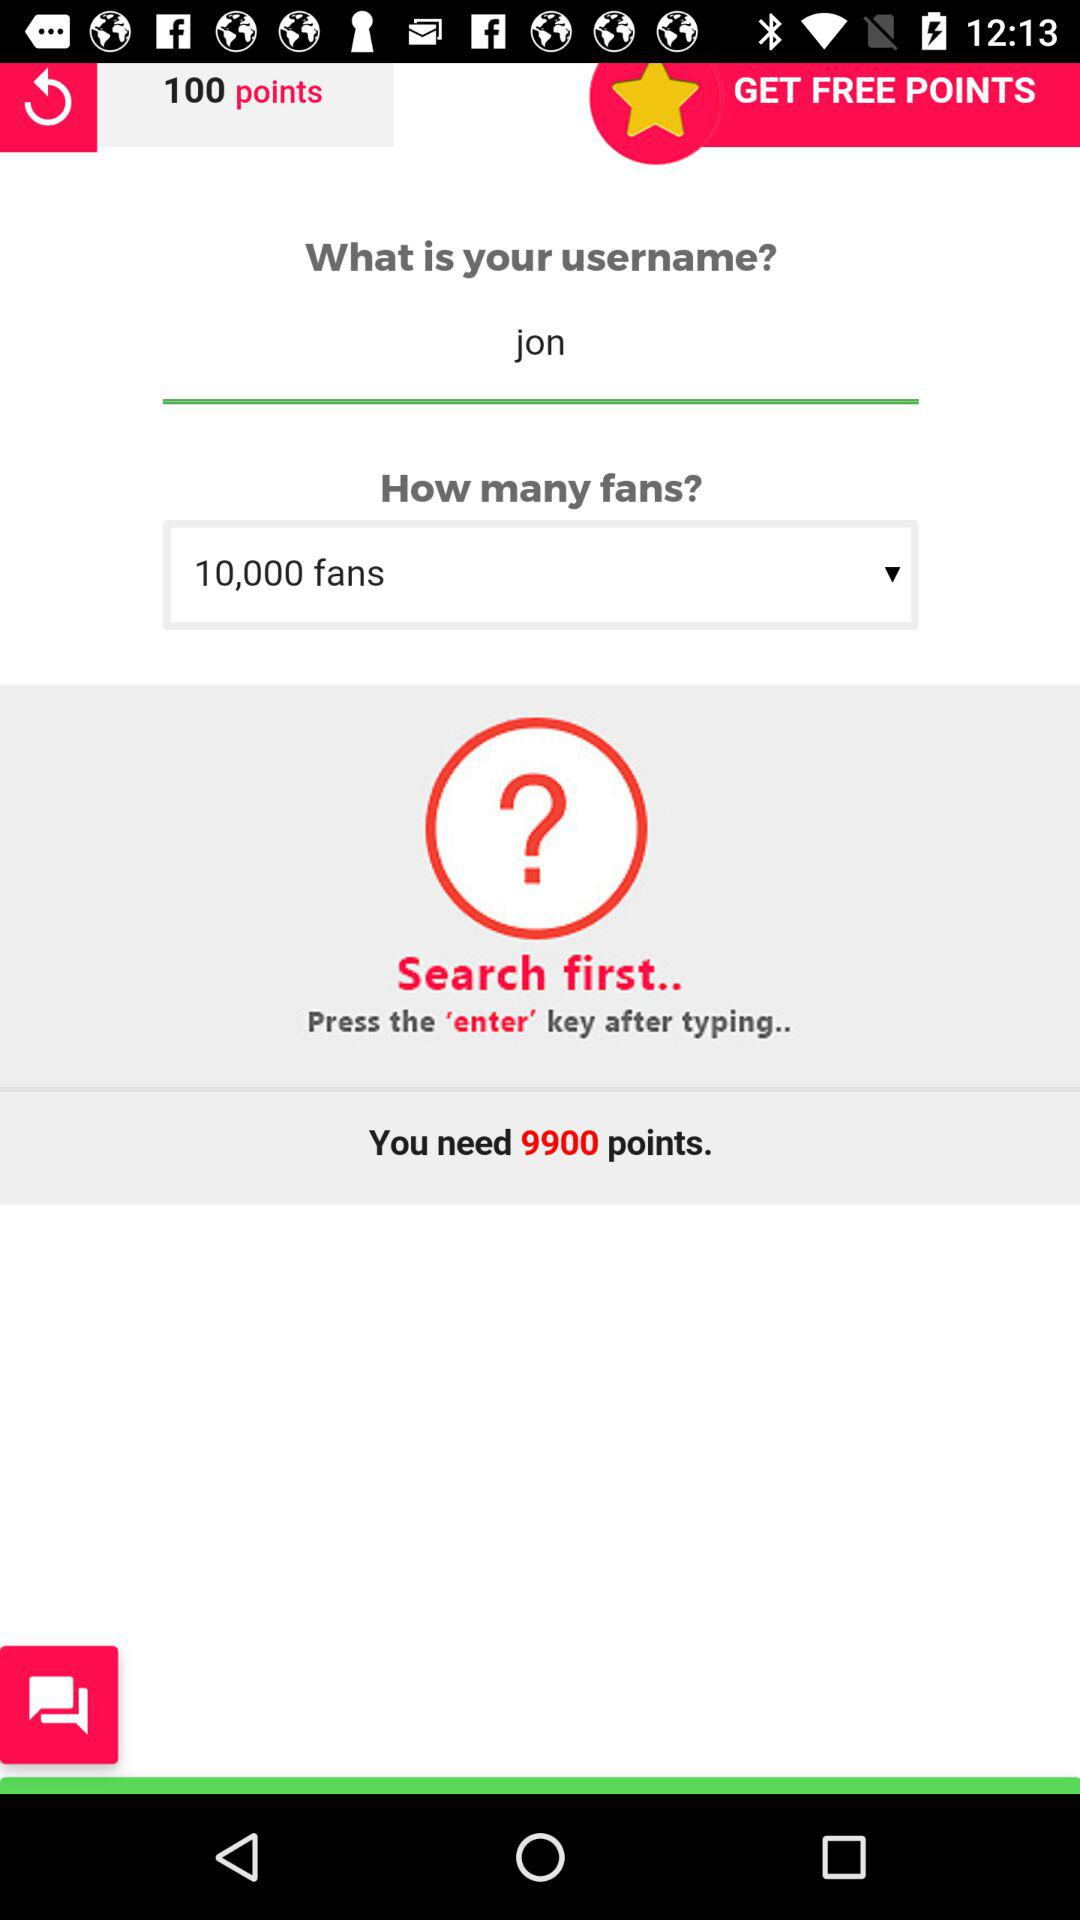What is the number of points that are saved? The number of saved points is 100. 